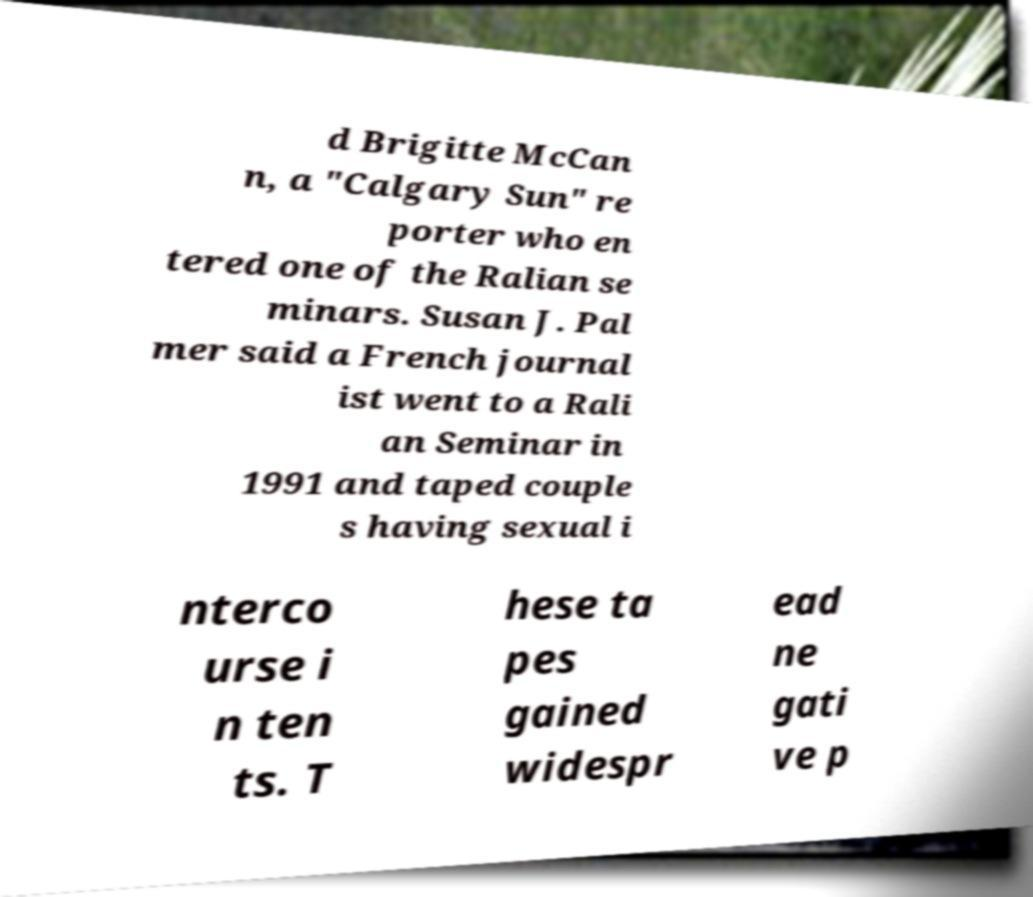Please read and relay the text visible in this image. What does it say? d Brigitte McCan n, a "Calgary Sun" re porter who en tered one of the Ralian se minars. Susan J. Pal mer said a French journal ist went to a Rali an Seminar in 1991 and taped couple s having sexual i nterco urse i n ten ts. T hese ta pes gained widespr ead ne gati ve p 